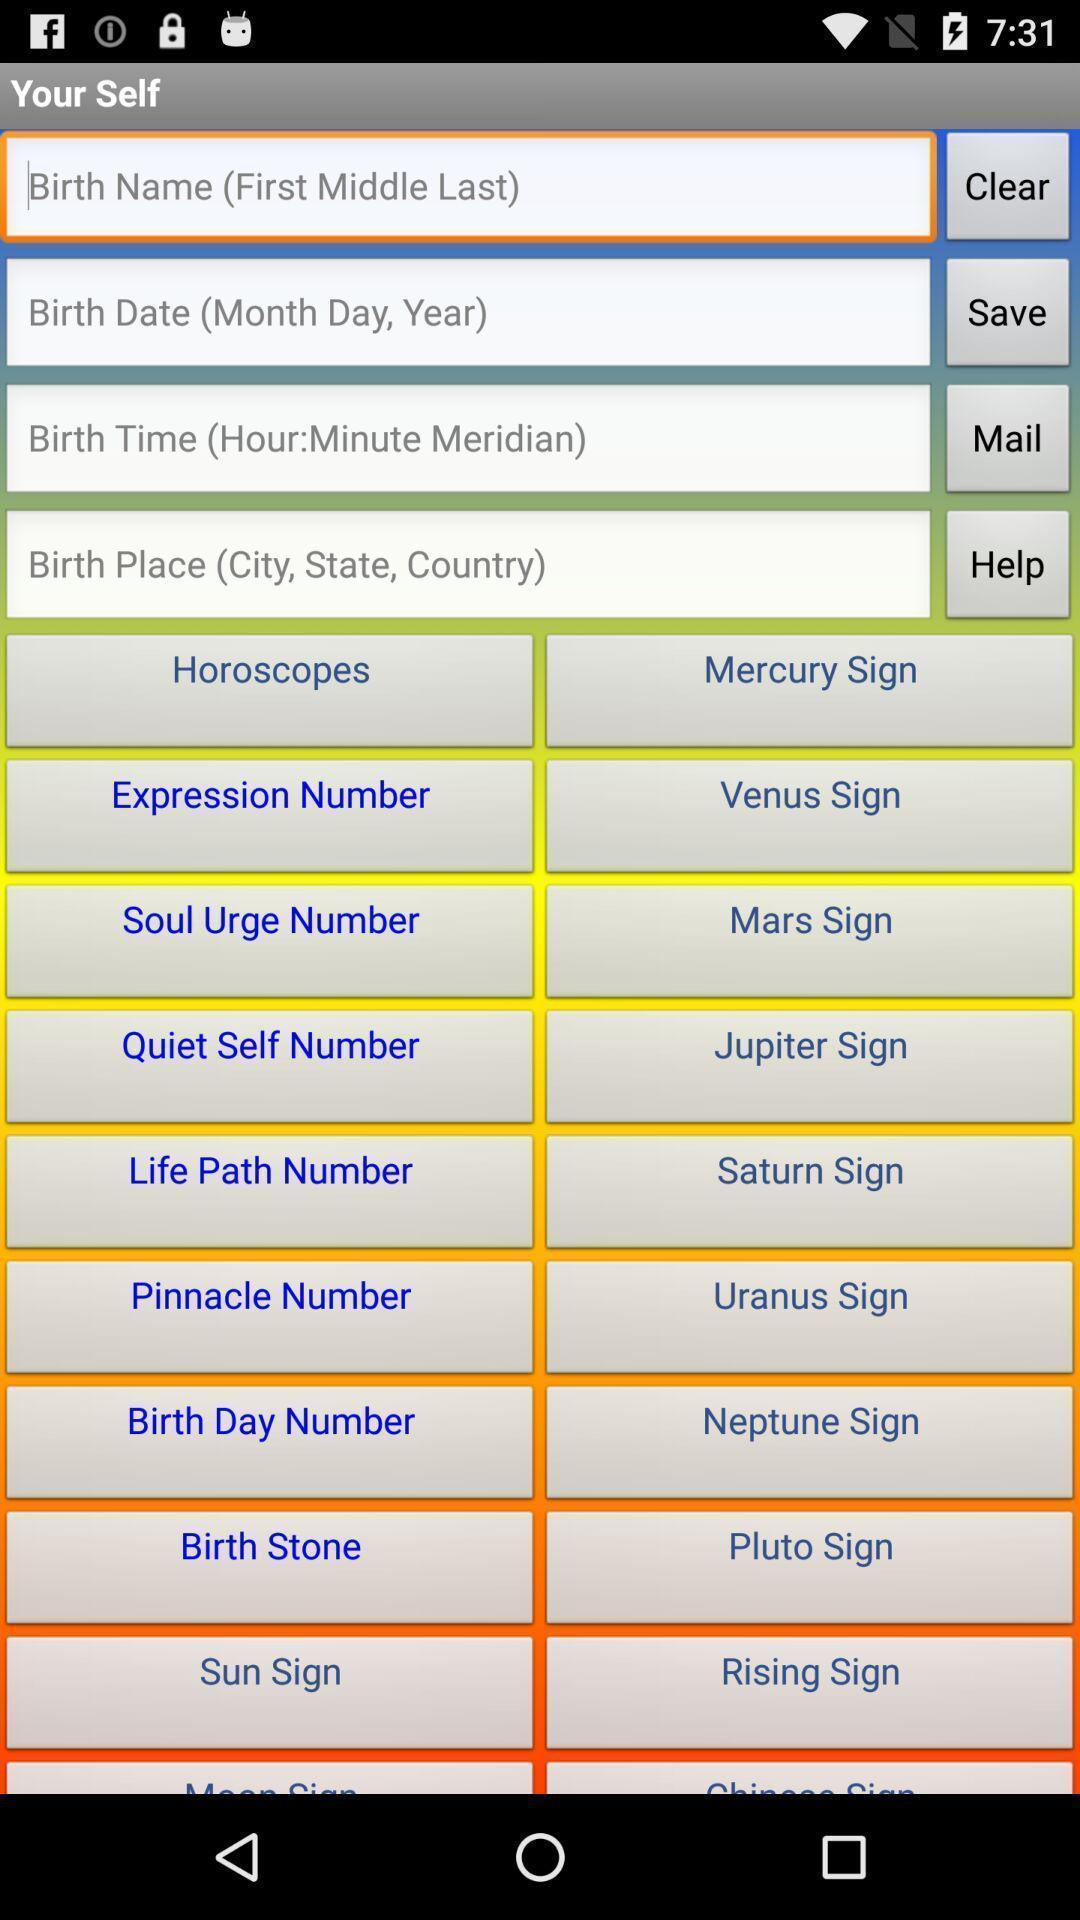Describe the content in this image. Window displaying list about yourself. 